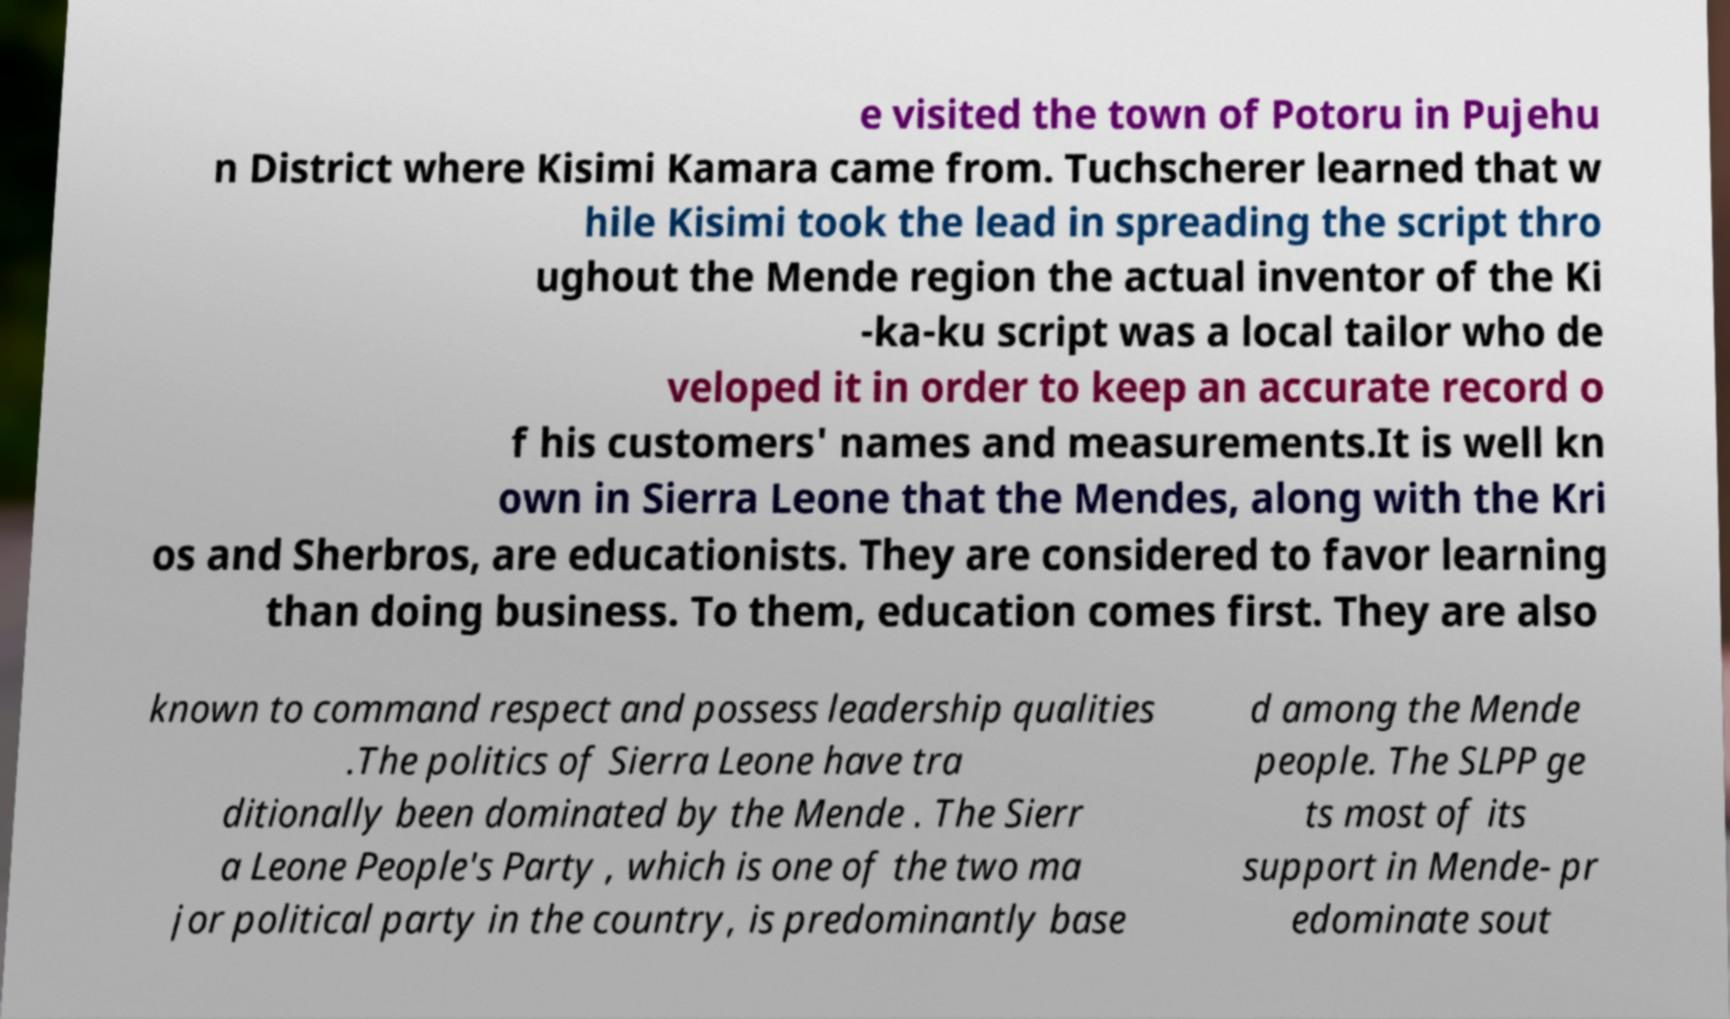There's text embedded in this image that I need extracted. Can you transcribe it verbatim? e visited the town of Potoru in Pujehu n District where Kisimi Kamara came from. Tuchscherer learned that w hile Kisimi took the lead in spreading the script thro ughout the Mende region the actual inventor of the Ki -ka-ku script was a local tailor who de veloped it in order to keep an accurate record o f his customers' names and measurements.It is well kn own in Sierra Leone that the Mendes, along with the Kri os and Sherbros, are educationists. They are considered to favor learning than doing business. To them, education comes first. They are also known to command respect and possess leadership qualities .The politics of Sierra Leone have tra ditionally been dominated by the Mende . The Sierr a Leone People's Party , which is one of the two ma jor political party in the country, is predominantly base d among the Mende people. The SLPP ge ts most of its support in Mende- pr edominate sout 